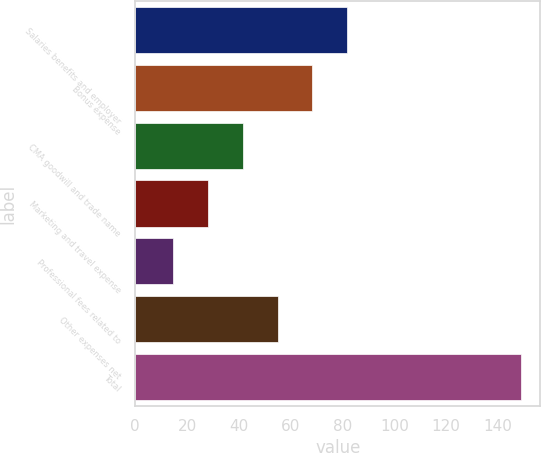Convert chart to OTSL. <chart><loc_0><loc_0><loc_500><loc_500><bar_chart><fcel>Salaries benefits and employer<fcel>Bonus expense<fcel>CMA goodwill and trade name<fcel>Marketing and travel expense<fcel>Professional fees related to<fcel>Other expenses net<fcel>Total<nl><fcel>81.8<fcel>68.38<fcel>41.54<fcel>28.12<fcel>14.7<fcel>54.96<fcel>148.9<nl></chart> 